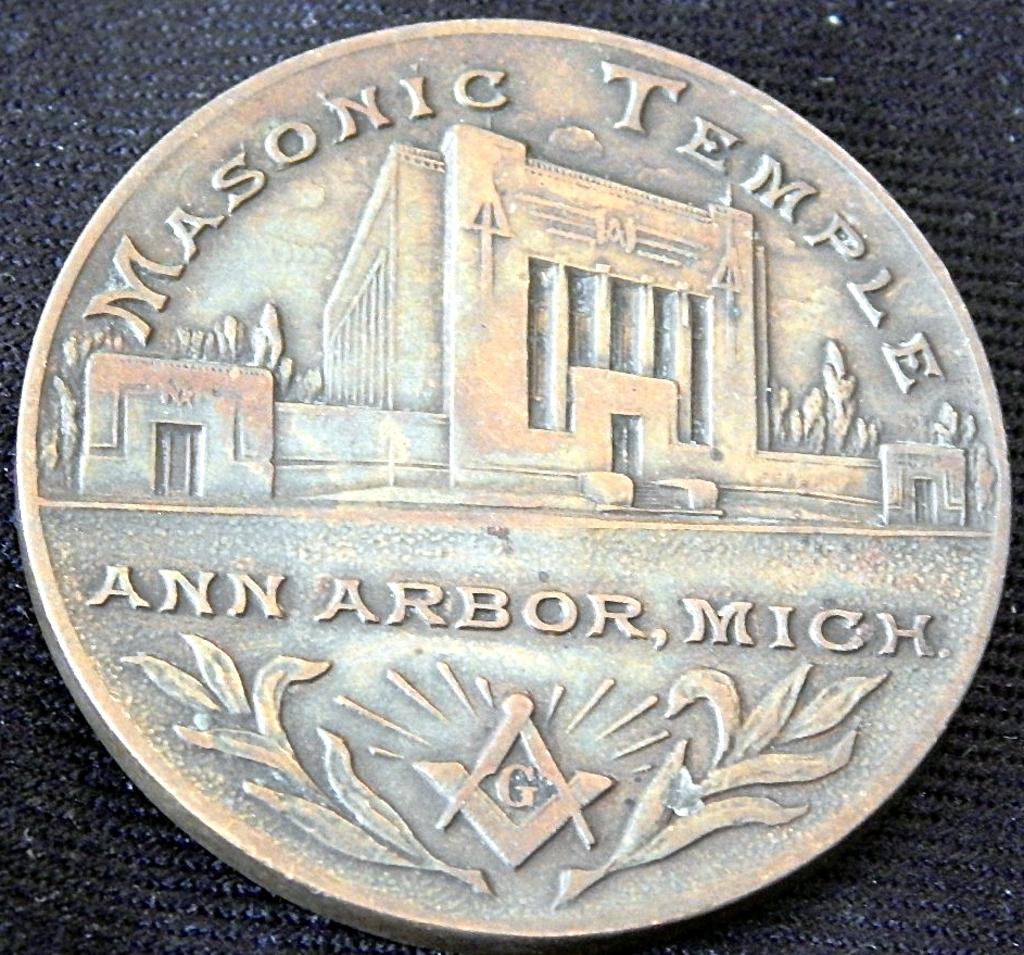<image>
Offer a succinct explanation of the picture presented. A coin for the Masonic Temple in Ann Arbor, Mich. shows a building. 